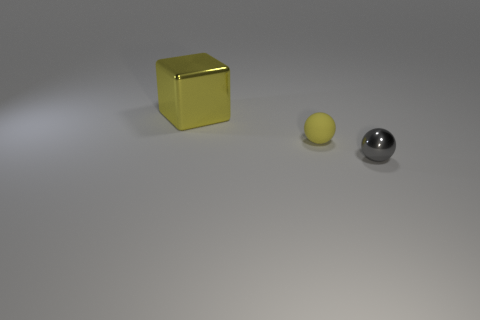Is there anything else that is the same size as the block?
Provide a succinct answer. No. How many other objects are there of the same size as the yellow shiny thing?
Your response must be concise. 0. There is a tiny thing left of the object right of the tiny yellow matte sphere that is to the left of the small gray metal ball; what is its material?
Give a very brief answer. Rubber. Is the shape of the gray metal thing the same as the matte thing?
Offer a terse response. Yes. How many metal objects are big things or small green balls?
Provide a succinct answer. 1. How many small things are there?
Make the answer very short. 2. What is the color of the rubber thing that is the same size as the gray ball?
Ensure brevity in your answer.  Yellow. Is the yellow block the same size as the gray object?
Give a very brief answer. No. What shape is the small matte object that is the same color as the large block?
Provide a succinct answer. Sphere. Do the shiny sphere and the yellow thing that is on the right side of the big yellow cube have the same size?
Provide a short and direct response. Yes. 